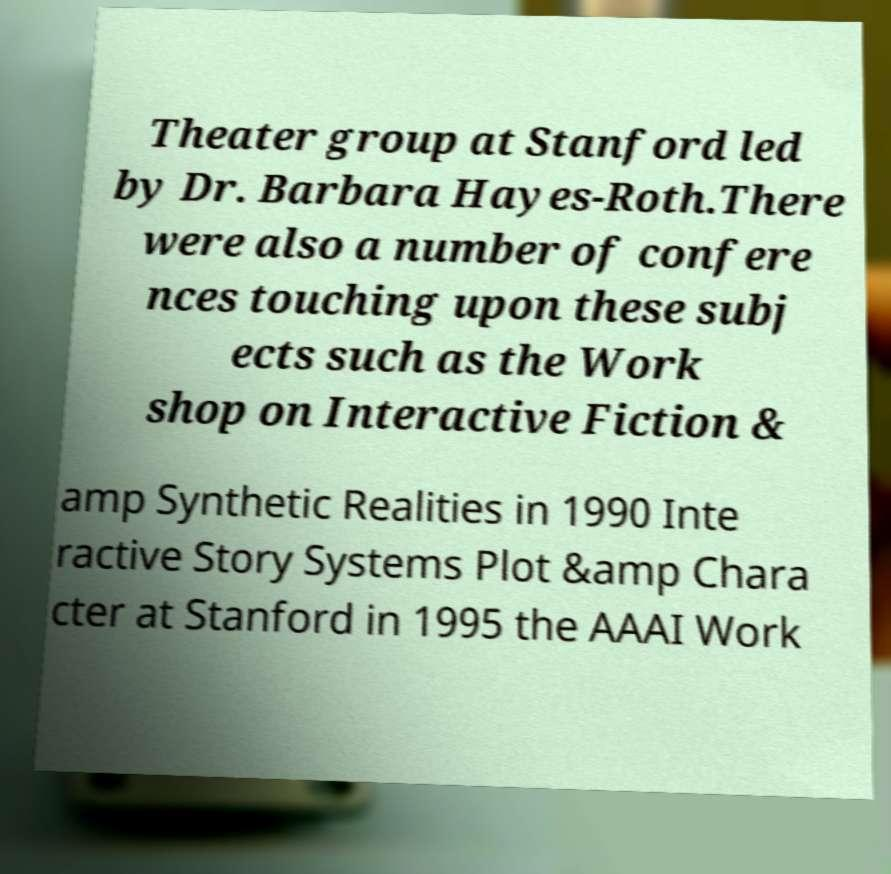Can you accurately transcribe the text from the provided image for me? Theater group at Stanford led by Dr. Barbara Hayes-Roth.There were also a number of confere nces touching upon these subj ects such as the Work shop on Interactive Fiction & amp Synthetic Realities in 1990 Inte ractive Story Systems Plot &amp Chara cter at Stanford in 1995 the AAAI Work 